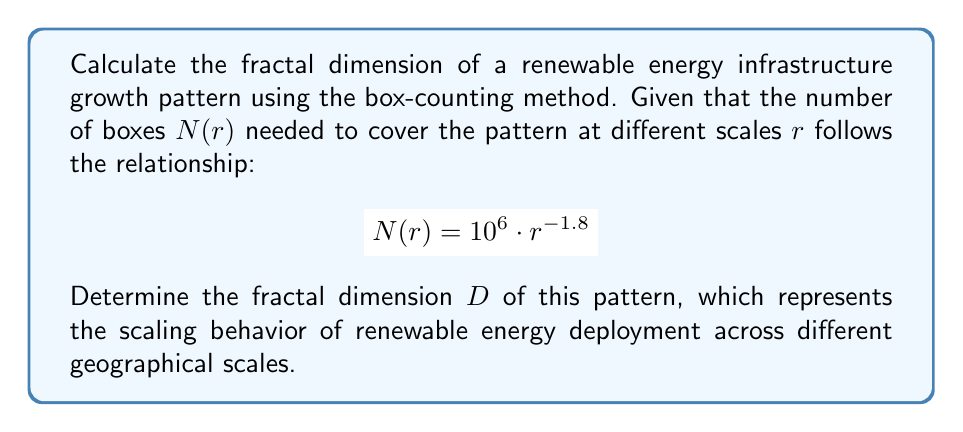Give your solution to this math problem. To determine the fractal dimension using the box-counting method, we follow these steps:

1. Recall the box-counting dimension formula:
   $$D = \lim_{r \to 0} \frac{\log N(r)}{\log(1/r)}$$

2. We are given the relationship $N(r) = 10^6 \cdot r^{-1.8}$

3. Take the logarithm of both sides:
   $$\log N(r) = \log(10^6 \cdot r^{-1.8})$$
   $$\log N(r) = \log(10^6) + \log(r^{-1.8})$$
   $$\log N(r) = 6 - 1.8 \log(r)$$

4. Rearrange to match the form of the box-counting dimension formula:
   $$\log N(r) = 6 + 1.8 \log(1/r)$$

5. The coefficient of $\log(1/r)$ gives us the fractal dimension:
   $$D = 1.8$$

This fractal dimension suggests that the renewable energy infrastructure growth pattern exhibits a scaling behavior between a line (D=1) and a plane (D=2), indicating a complex, space-filling distribution across different geographical scales.
Answer: $D = 1.8$ 